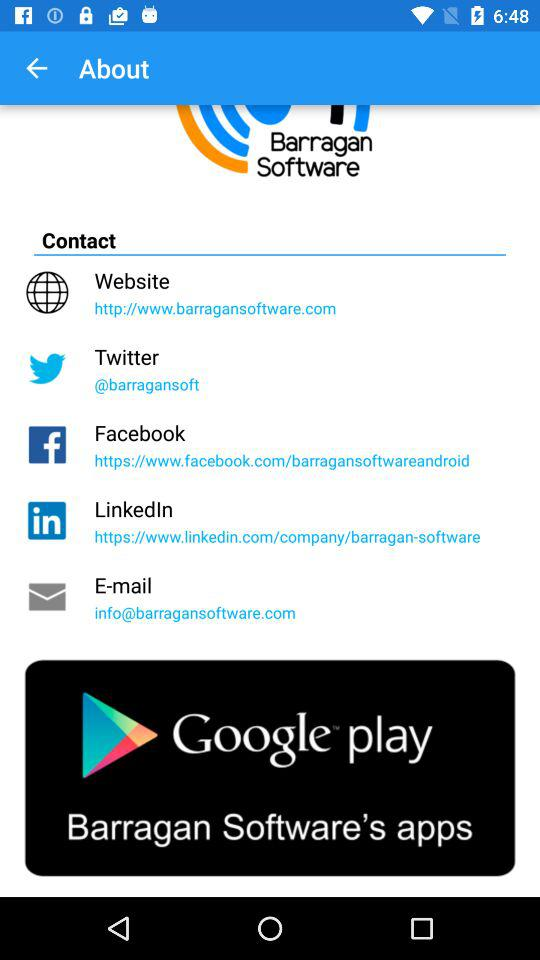How many contact options are available on this screen?
Answer the question using a single word or phrase. 5 